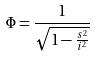Convert formula to latex. <formula><loc_0><loc_0><loc_500><loc_500>\Phi = \frac { 1 } { \sqrt { 1 - \frac { s ^ { 2 } } { i ^ { 2 } } } }</formula> 